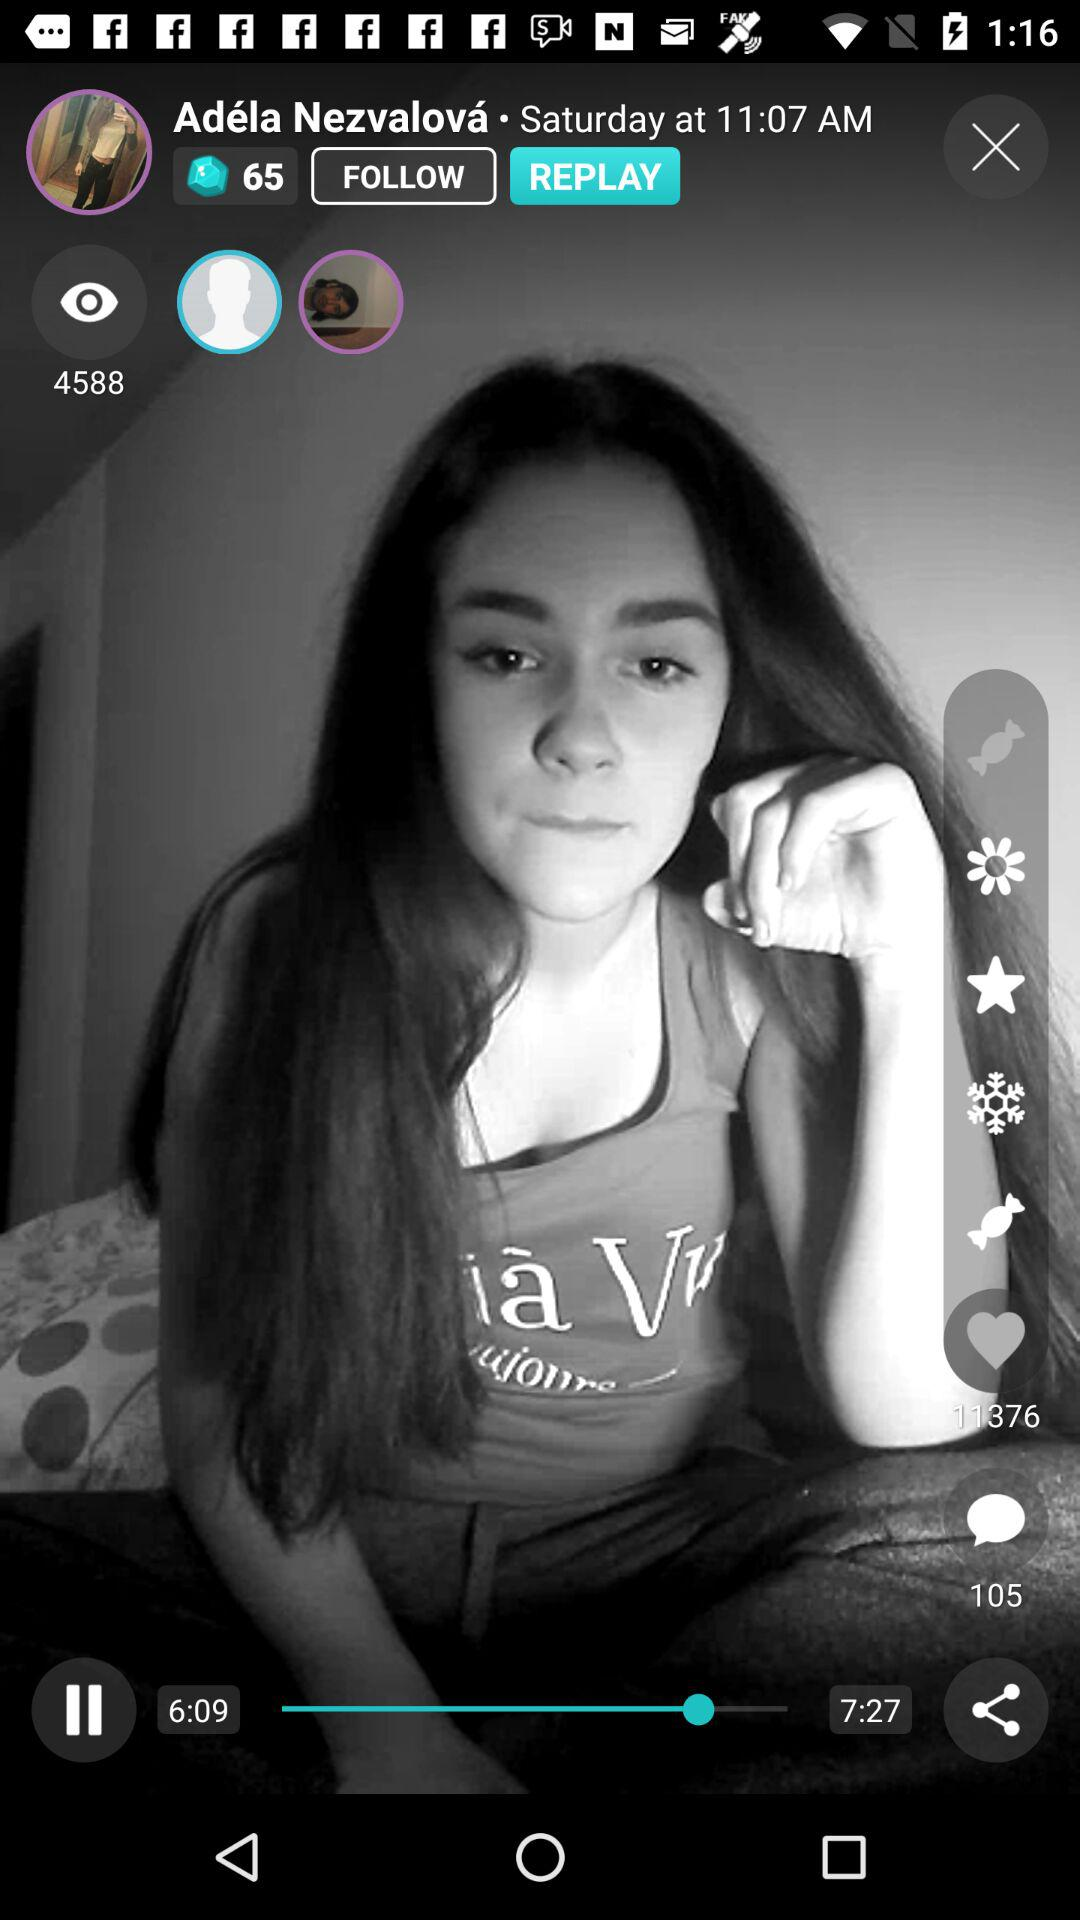What is the total number of comments? The total number is 105. 